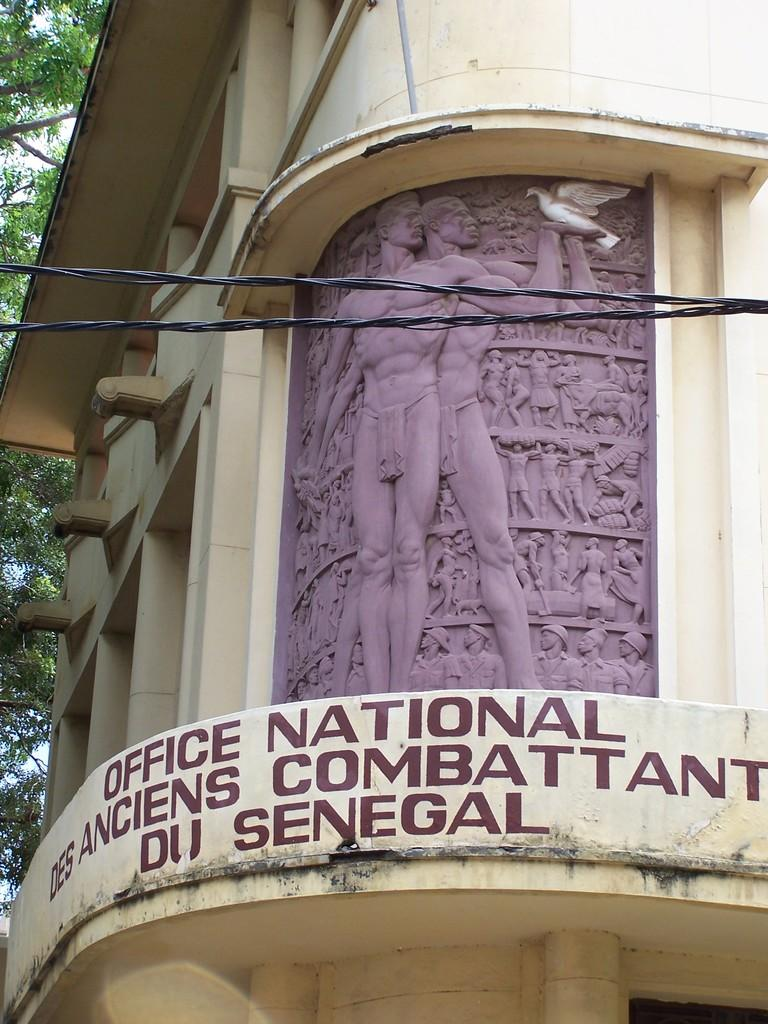What type of artwork can be seen in the image? There are sculptures in the image. What else is present on the building in the image? There is text on a building in the image. What other objects can be seen in the image? Cables are visible in the image. What can be seen in the background of the image? There are trees in the background of the image. What type of cave can be seen in the image? There is no cave present in the image. What kind of badge is being worn by the sculptures in the image? There are no people or badges visible in the image, only sculptures. 